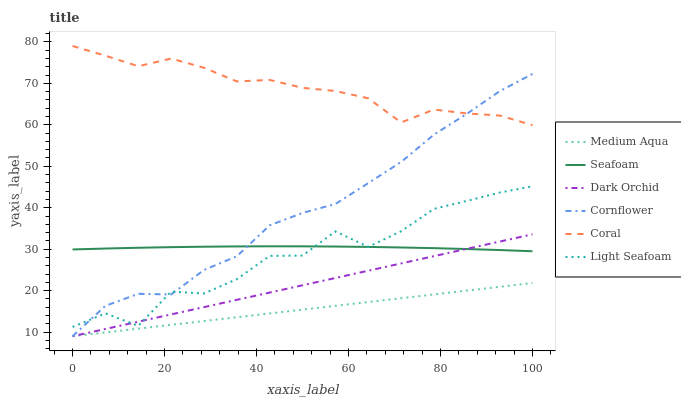Does Medium Aqua have the minimum area under the curve?
Answer yes or no. Yes. Does Coral have the maximum area under the curve?
Answer yes or no. Yes. Does Seafoam have the minimum area under the curve?
Answer yes or no. No. Does Seafoam have the maximum area under the curve?
Answer yes or no. No. Is Medium Aqua the smoothest?
Answer yes or no. Yes. Is Light Seafoam the roughest?
Answer yes or no. Yes. Is Coral the smoothest?
Answer yes or no. No. Is Coral the roughest?
Answer yes or no. No. Does Cornflower have the lowest value?
Answer yes or no. Yes. Does Seafoam have the lowest value?
Answer yes or no. No. Does Coral have the highest value?
Answer yes or no. Yes. Does Seafoam have the highest value?
Answer yes or no. No. Is Dark Orchid less than Coral?
Answer yes or no. Yes. Is Seafoam greater than Medium Aqua?
Answer yes or no. Yes. Does Medium Aqua intersect Dark Orchid?
Answer yes or no. Yes. Is Medium Aqua less than Dark Orchid?
Answer yes or no. No. Is Medium Aqua greater than Dark Orchid?
Answer yes or no. No. Does Dark Orchid intersect Coral?
Answer yes or no. No. 